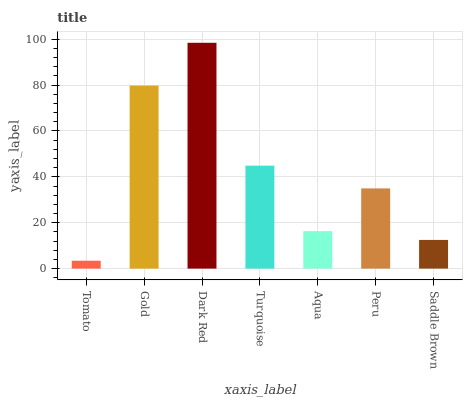Is Tomato the minimum?
Answer yes or no. Yes. Is Dark Red the maximum?
Answer yes or no. Yes. Is Gold the minimum?
Answer yes or no. No. Is Gold the maximum?
Answer yes or no. No. Is Gold greater than Tomato?
Answer yes or no. Yes. Is Tomato less than Gold?
Answer yes or no. Yes. Is Tomato greater than Gold?
Answer yes or no. No. Is Gold less than Tomato?
Answer yes or no. No. Is Peru the high median?
Answer yes or no. Yes. Is Peru the low median?
Answer yes or no. Yes. Is Saddle Brown the high median?
Answer yes or no. No. Is Aqua the low median?
Answer yes or no. No. 